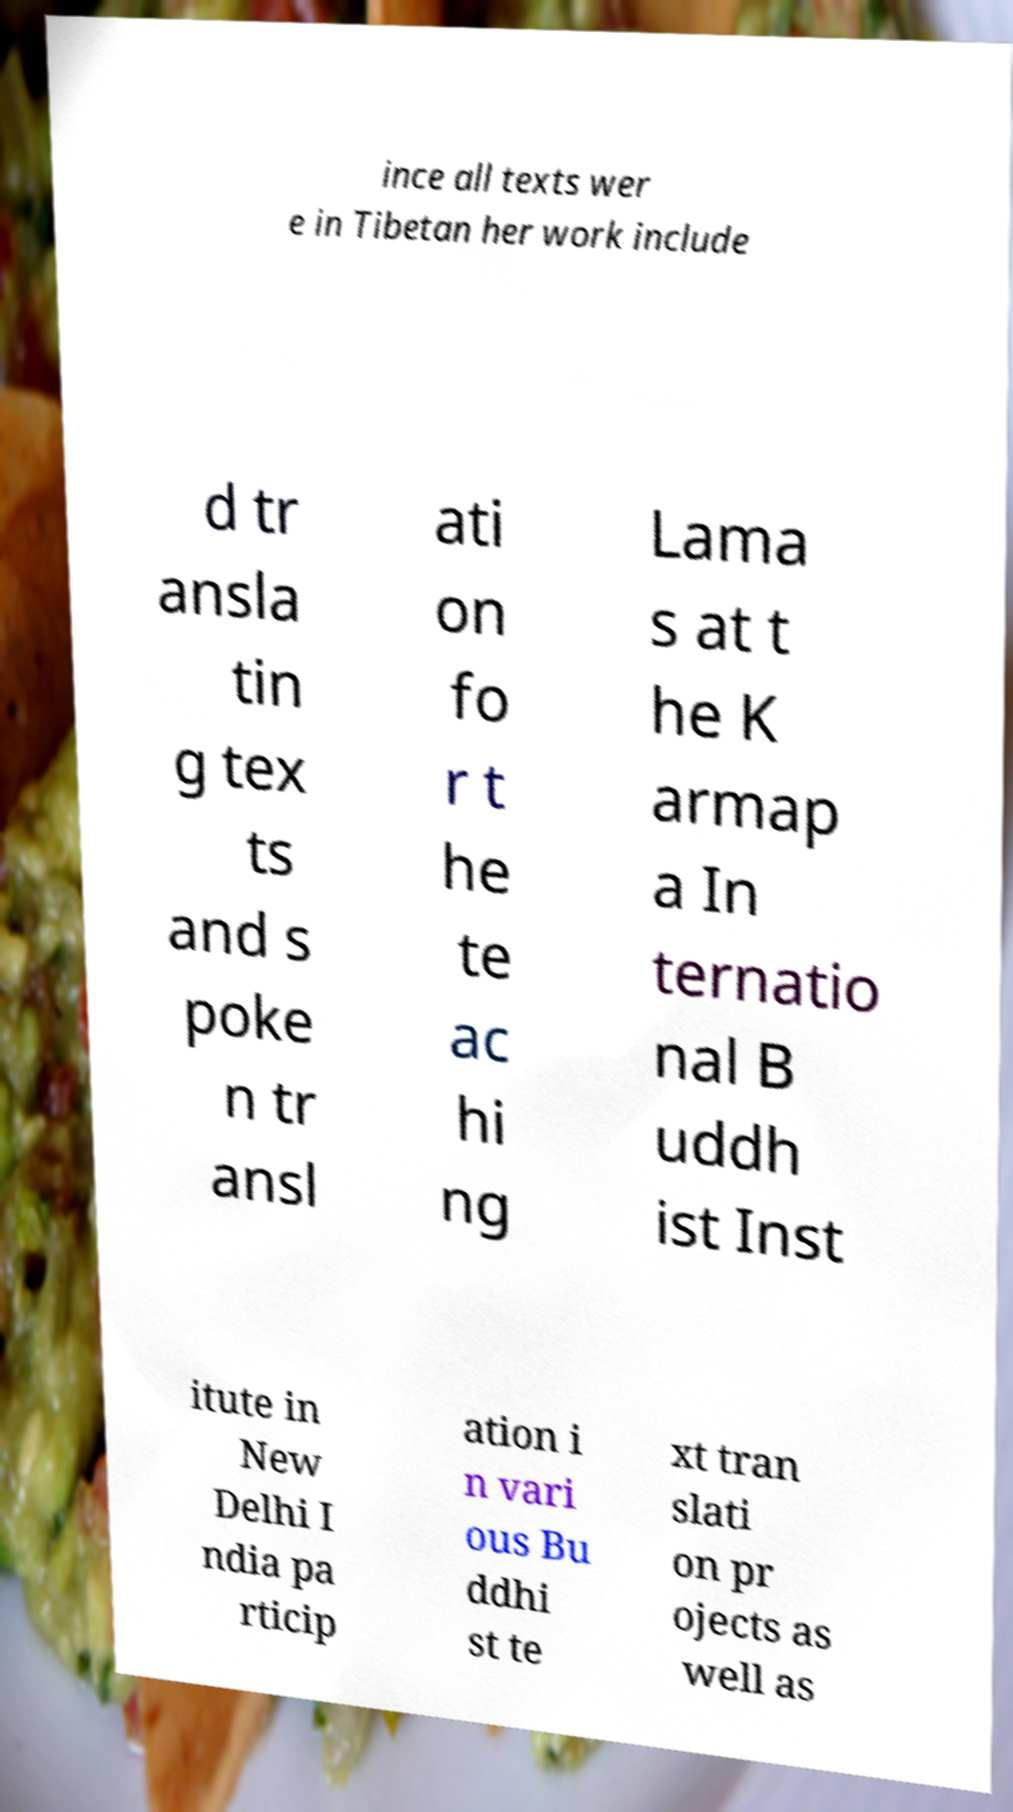Can you accurately transcribe the text from the provided image for me? ince all texts wer e in Tibetan her work include d tr ansla tin g tex ts and s poke n tr ansl ati on fo r t he te ac hi ng Lama s at t he K armap a In ternatio nal B uddh ist Inst itute in New Delhi I ndia pa rticip ation i n vari ous Bu ddhi st te xt tran slati on pr ojects as well as 